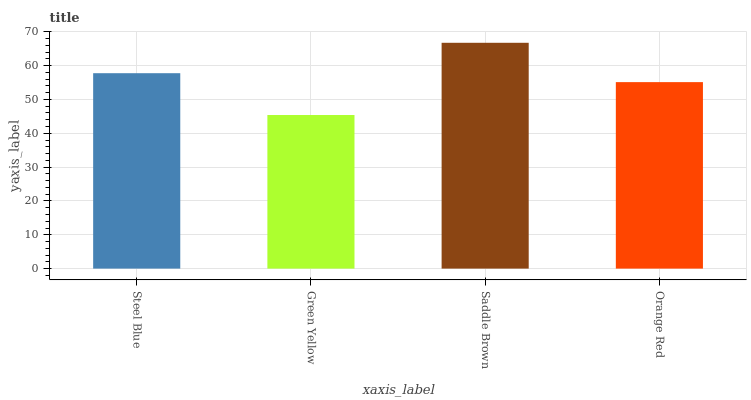Is Saddle Brown the minimum?
Answer yes or no. No. Is Green Yellow the maximum?
Answer yes or no. No. Is Saddle Brown greater than Green Yellow?
Answer yes or no. Yes. Is Green Yellow less than Saddle Brown?
Answer yes or no. Yes. Is Green Yellow greater than Saddle Brown?
Answer yes or no. No. Is Saddle Brown less than Green Yellow?
Answer yes or no. No. Is Steel Blue the high median?
Answer yes or no. Yes. Is Orange Red the low median?
Answer yes or no. Yes. Is Green Yellow the high median?
Answer yes or no. No. Is Steel Blue the low median?
Answer yes or no. No. 